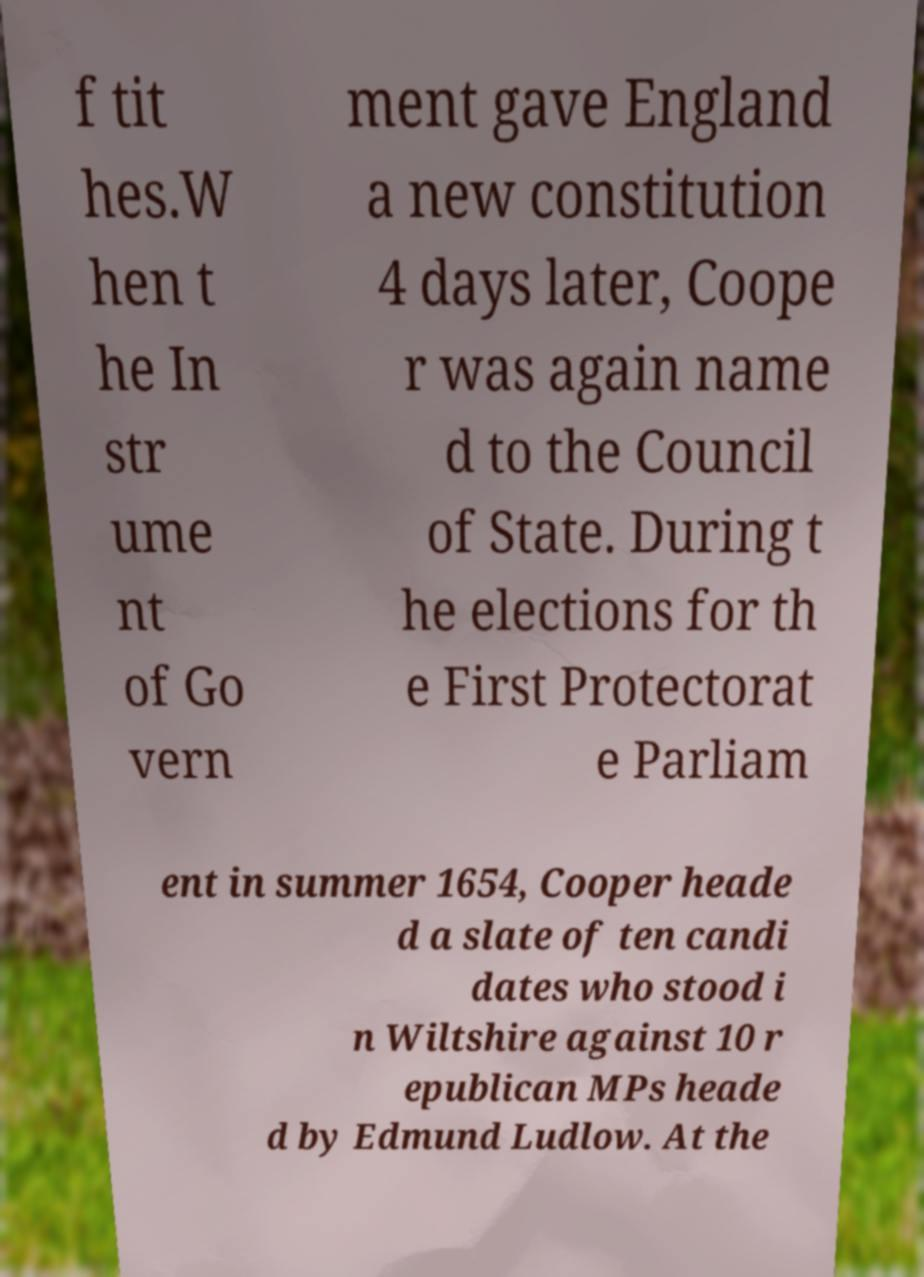What messages or text are displayed in this image? I need them in a readable, typed format. f tit hes.W hen t he In str ume nt of Go vern ment gave England a new constitution 4 days later, Coope r was again name d to the Council of State. During t he elections for th e First Protectorat e Parliam ent in summer 1654, Cooper heade d a slate of ten candi dates who stood i n Wiltshire against 10 r epublican MPs heade d by Edmund Ludlow. At the 